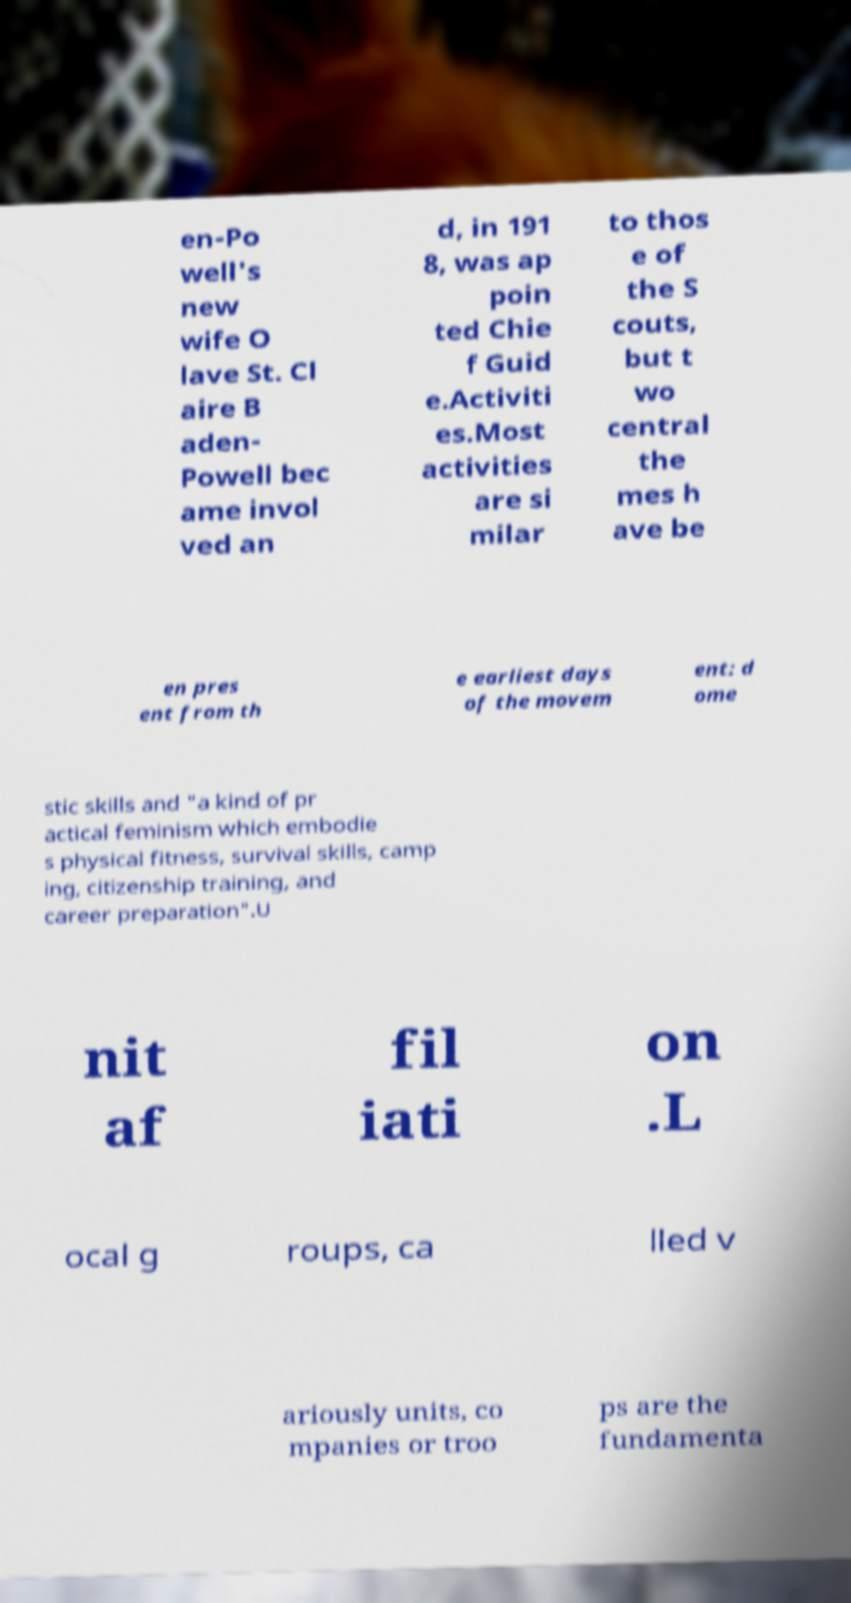Please read and relay the text visible in this image. What does it say? en-Po well's new wife O lave St. Cl aire B aden- Powell bec ame invol ved an d, in 191 8, was ap poin ted Chie f Guid e.Activiti es.Most activities are si milar to thos e of the S couts, but t wo central the mes h ave be en pres ent from th e earliest days of the movem ent: d ome stic skills and "a kind of pr actical feminism which embodie s physical fitness, survival skills, camp ing, citizenship training, and career preparation".U nit af fil iati on .L ocal g roups, ca lled v ariously units, co mpanies or troo ps are the fundamenta 